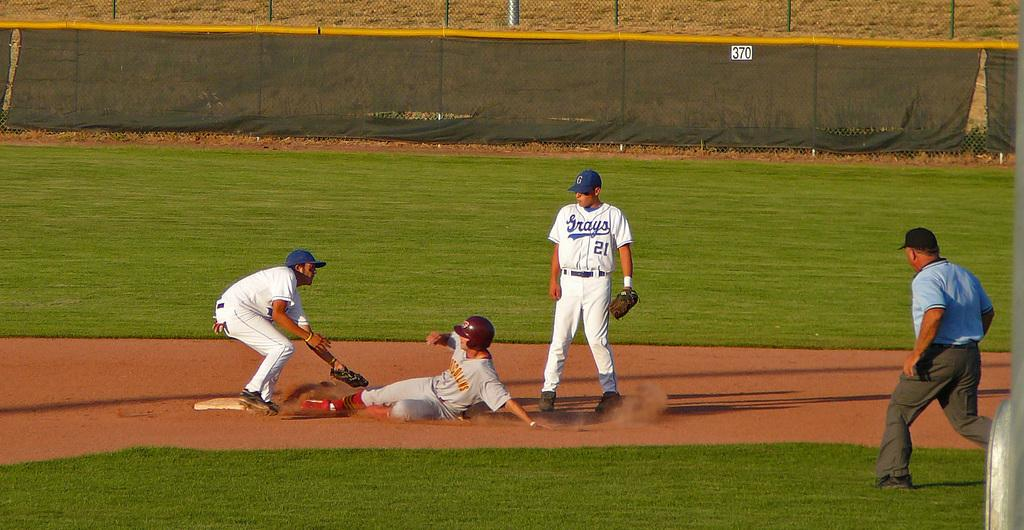What color are the dresses worn by the players in the image? The players are wearing white color dresses in the image. What action is being performed by one of the players? One person is running in the image. What type of barrier is present in the image? There is net fencing visible in the image. Is there any additional element attached to the net fencing? Yes, there is a cloth on the net fencing. What type of cub is visible in the image? There is no cub present in the image. What kind of operation is being performed by the players in the image? The image does not depict any specific operation being performed by the players; they are simply wearing white dresses and one person is running. 